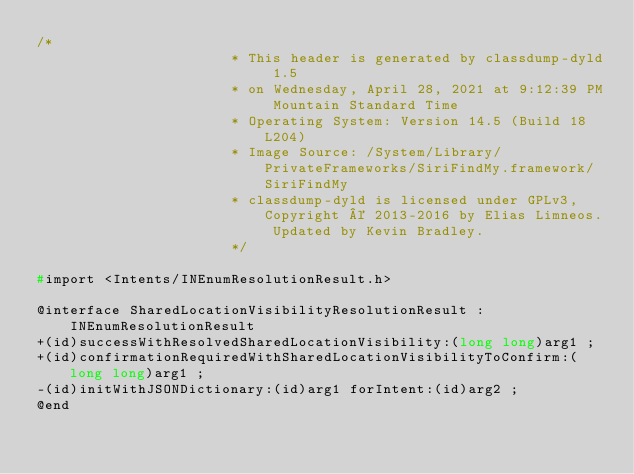Convert code to text. <code><loc_0><loc_0><loc_500><loc_500><_C_>/*
                       * This header is generated by classdump-dyld 1.5
                       * on Wednesday, April 28, 2021 at 9:12:39 PM Mountain Standard Time
                       * Operating System: Version 14.5 (Build 18L204)
                       * Image Source: /System/Library/PrivateFrameworks/SiriFindMy.framework/SiriFindMy
                       * classdump-dyld is licensed under GPLv3, Copyright © 2013-2016 by Elias Limneos. Updated by Kevin Bradley.
                       */

#import <Intents/INEnumResolutionResult.h>

@interface SharedLocationVisibilityResolutionResult : INEnumResolutionResult
+(id)successWithResolvedSharedLocationVisibility:(long long)arg1 ;
+(id)confirmationRequiredWithSharedLocationVisibilityToConfirm:(long long)arg1 ;
-(id)initWithJSONDictionary:(id)arg1 forIntent:(id)arg2 ;
@end

</code> 